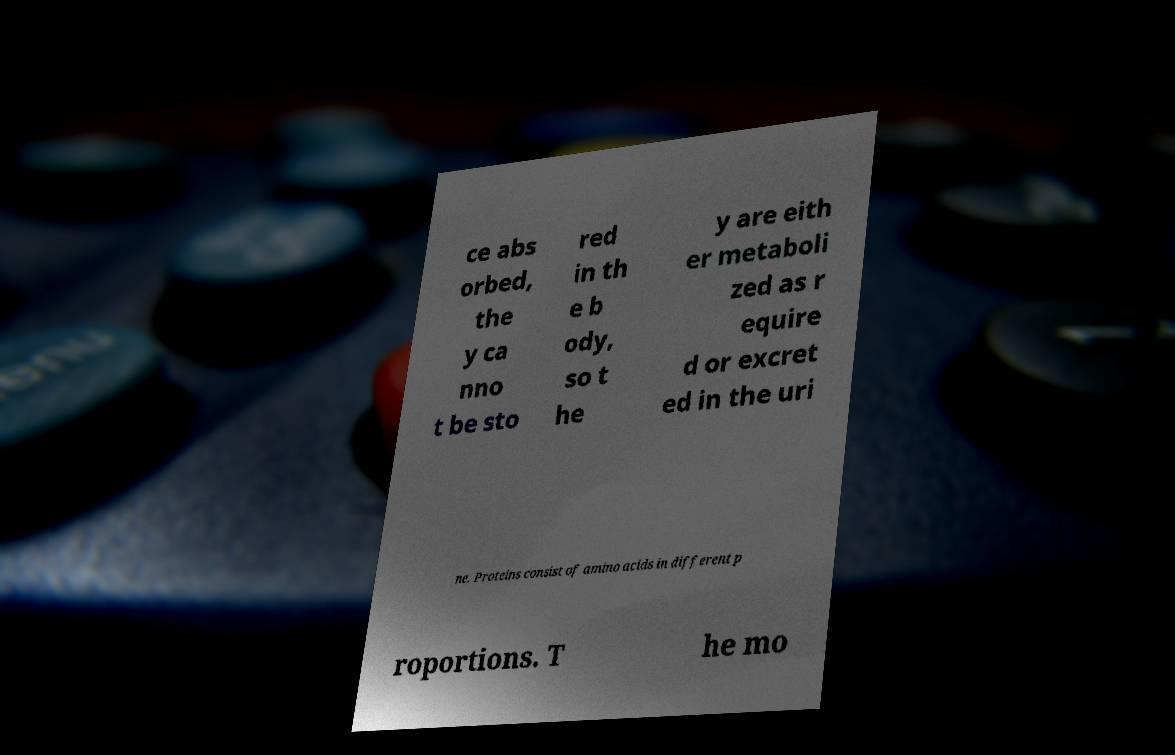Please read and relay the text visible in this image. What does it say? ce abs orbed, the y ca nno t be sto red in th e b ody, so t he y are eith er metaboli zed as r equire d or excret ed in the uri ne. Proteins consist of amino acids in different p roportions. T he mo 